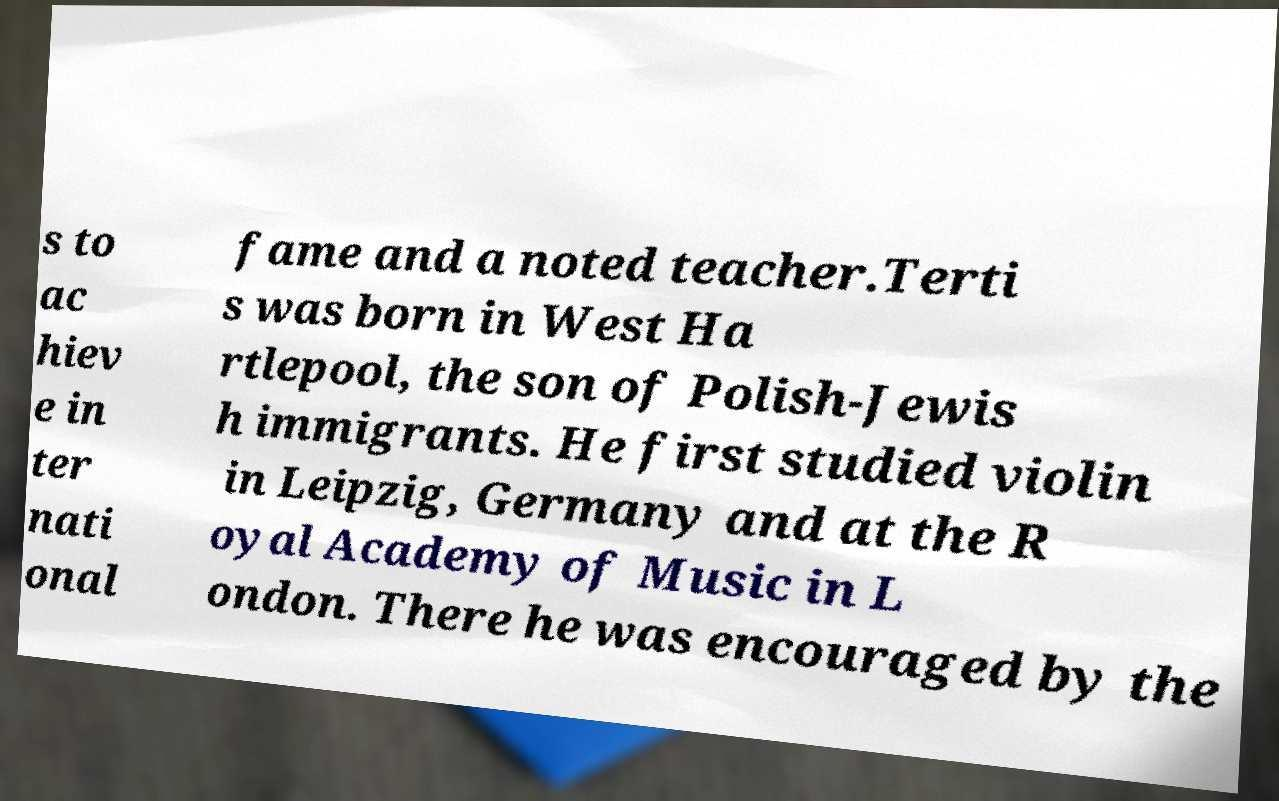There's text embedded in this image that I need extracted. Can you transcribe it verbatim? s to ac hiev e in ter nati onal fame and a noted teacher.Terti s was born in West Ha rtlepool, the son of Polish-Jewis h immigrants. He first studied violin in Leipzig, Germany and at the R oyal Academy of Music in L ondon. There he was encouraged by the 